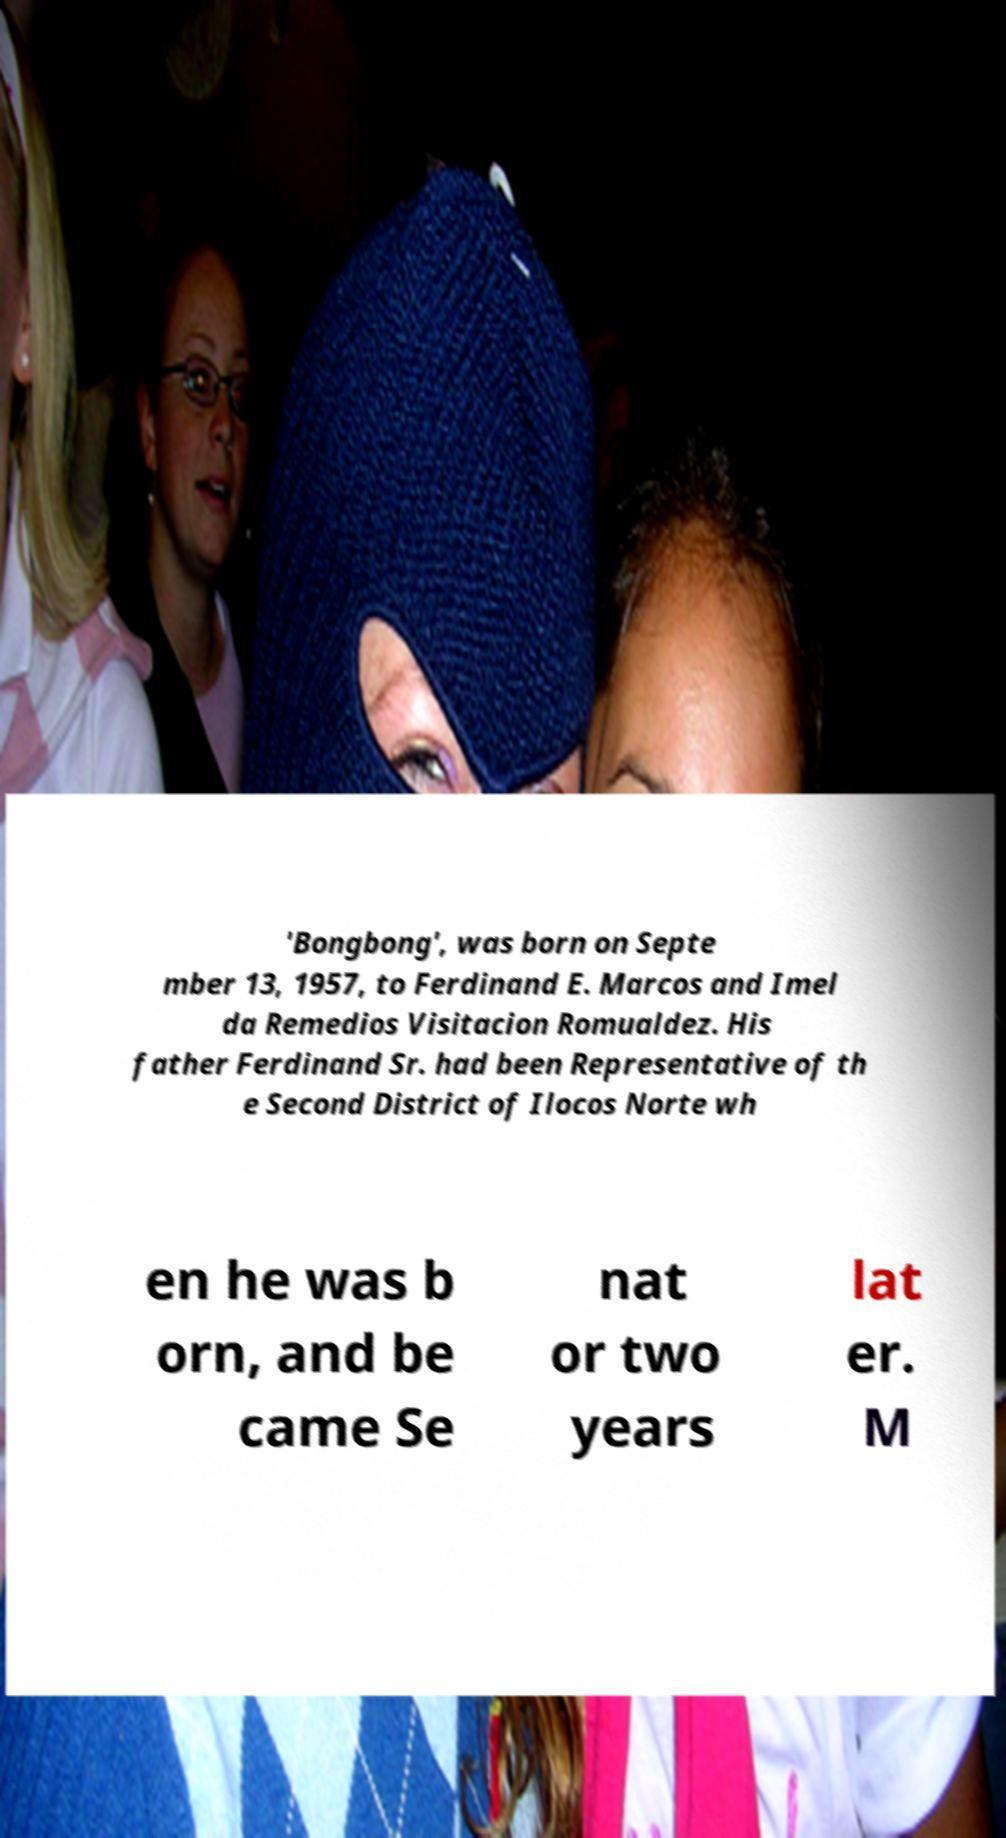Can you read and provide the text displayed in the image?This photo seems to have some interesting text. Can you extract and type it out for me? 'Bongbong', was born on Septe mber 13, 1957, to Ferdinand E. Marcos and Imel da Remedios Visitacion Romualdez. His father Ferdinand Sr. had been Representative of th e Second District of Ilocos Norte wh en he was b orn, and be came Se nat or two years lat er. M 